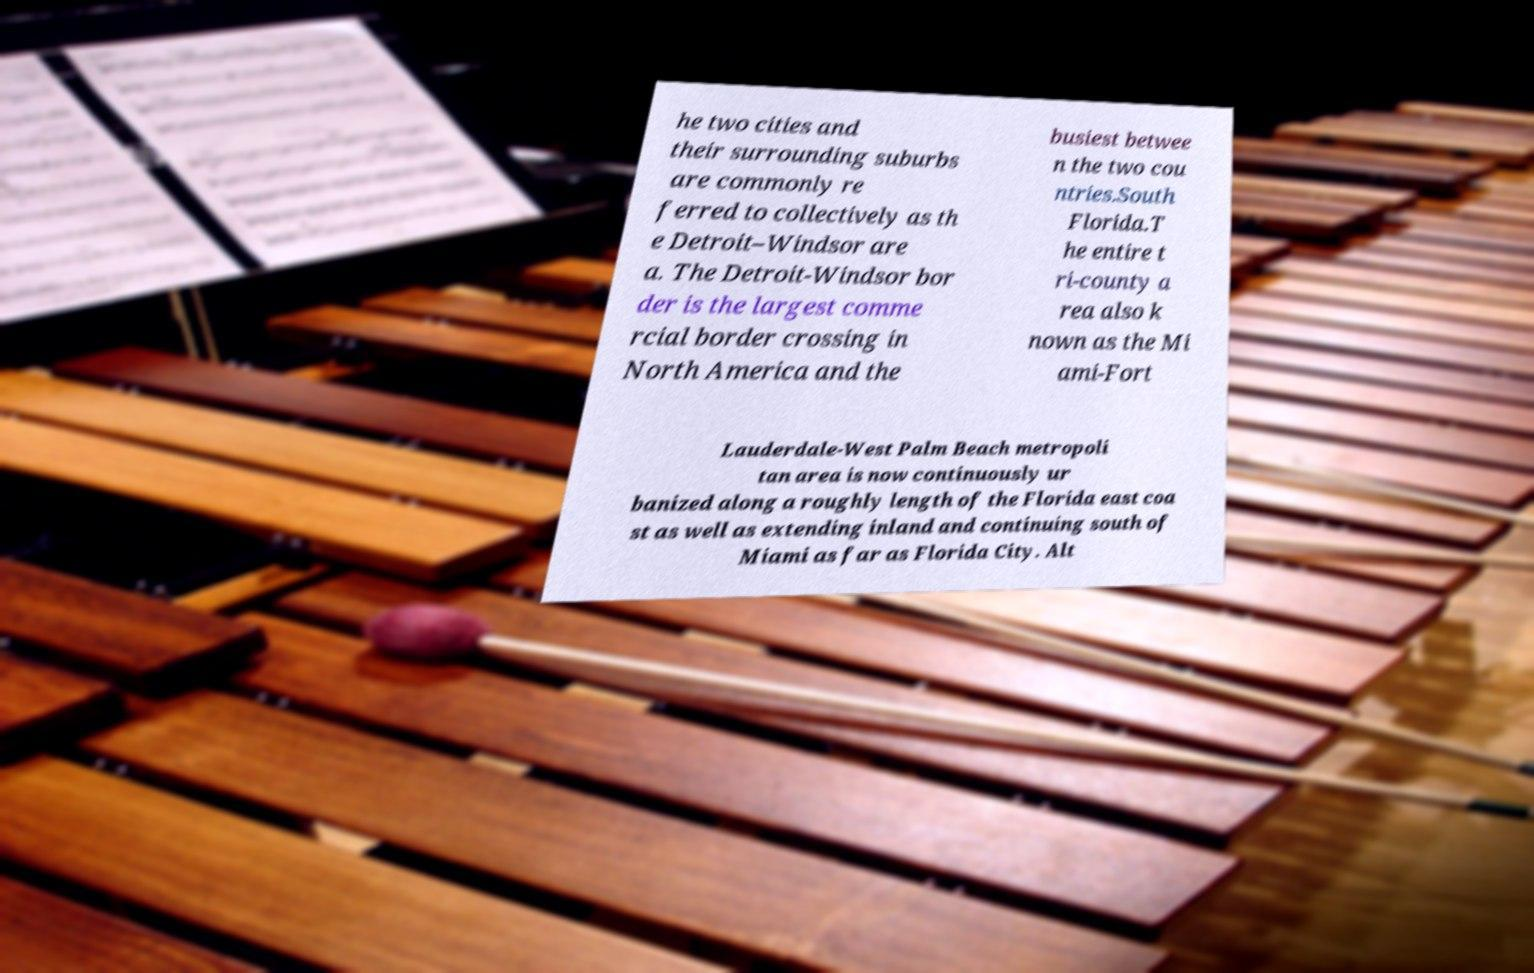What messages or text are displayed in this image? I need them in a readable, typed format. he two cities and their surrounding suburbs are commonly re ferred to collectively as th e Detroit–Windsor are a. The Detroit-Windsor bor der is the largest comme rcial border crossing in North America and the busiest betwee n the two cou ntries.South Florida.T he entire t ri-county a rea also k nown as the Mi ami-Fort Lauderdale-West Palm Beach metropoli tan area is now continuously ur banized along a roughly length of the Florida east coa st as well as extending inland and continuing south of Miami as far as Florida City. Alt 